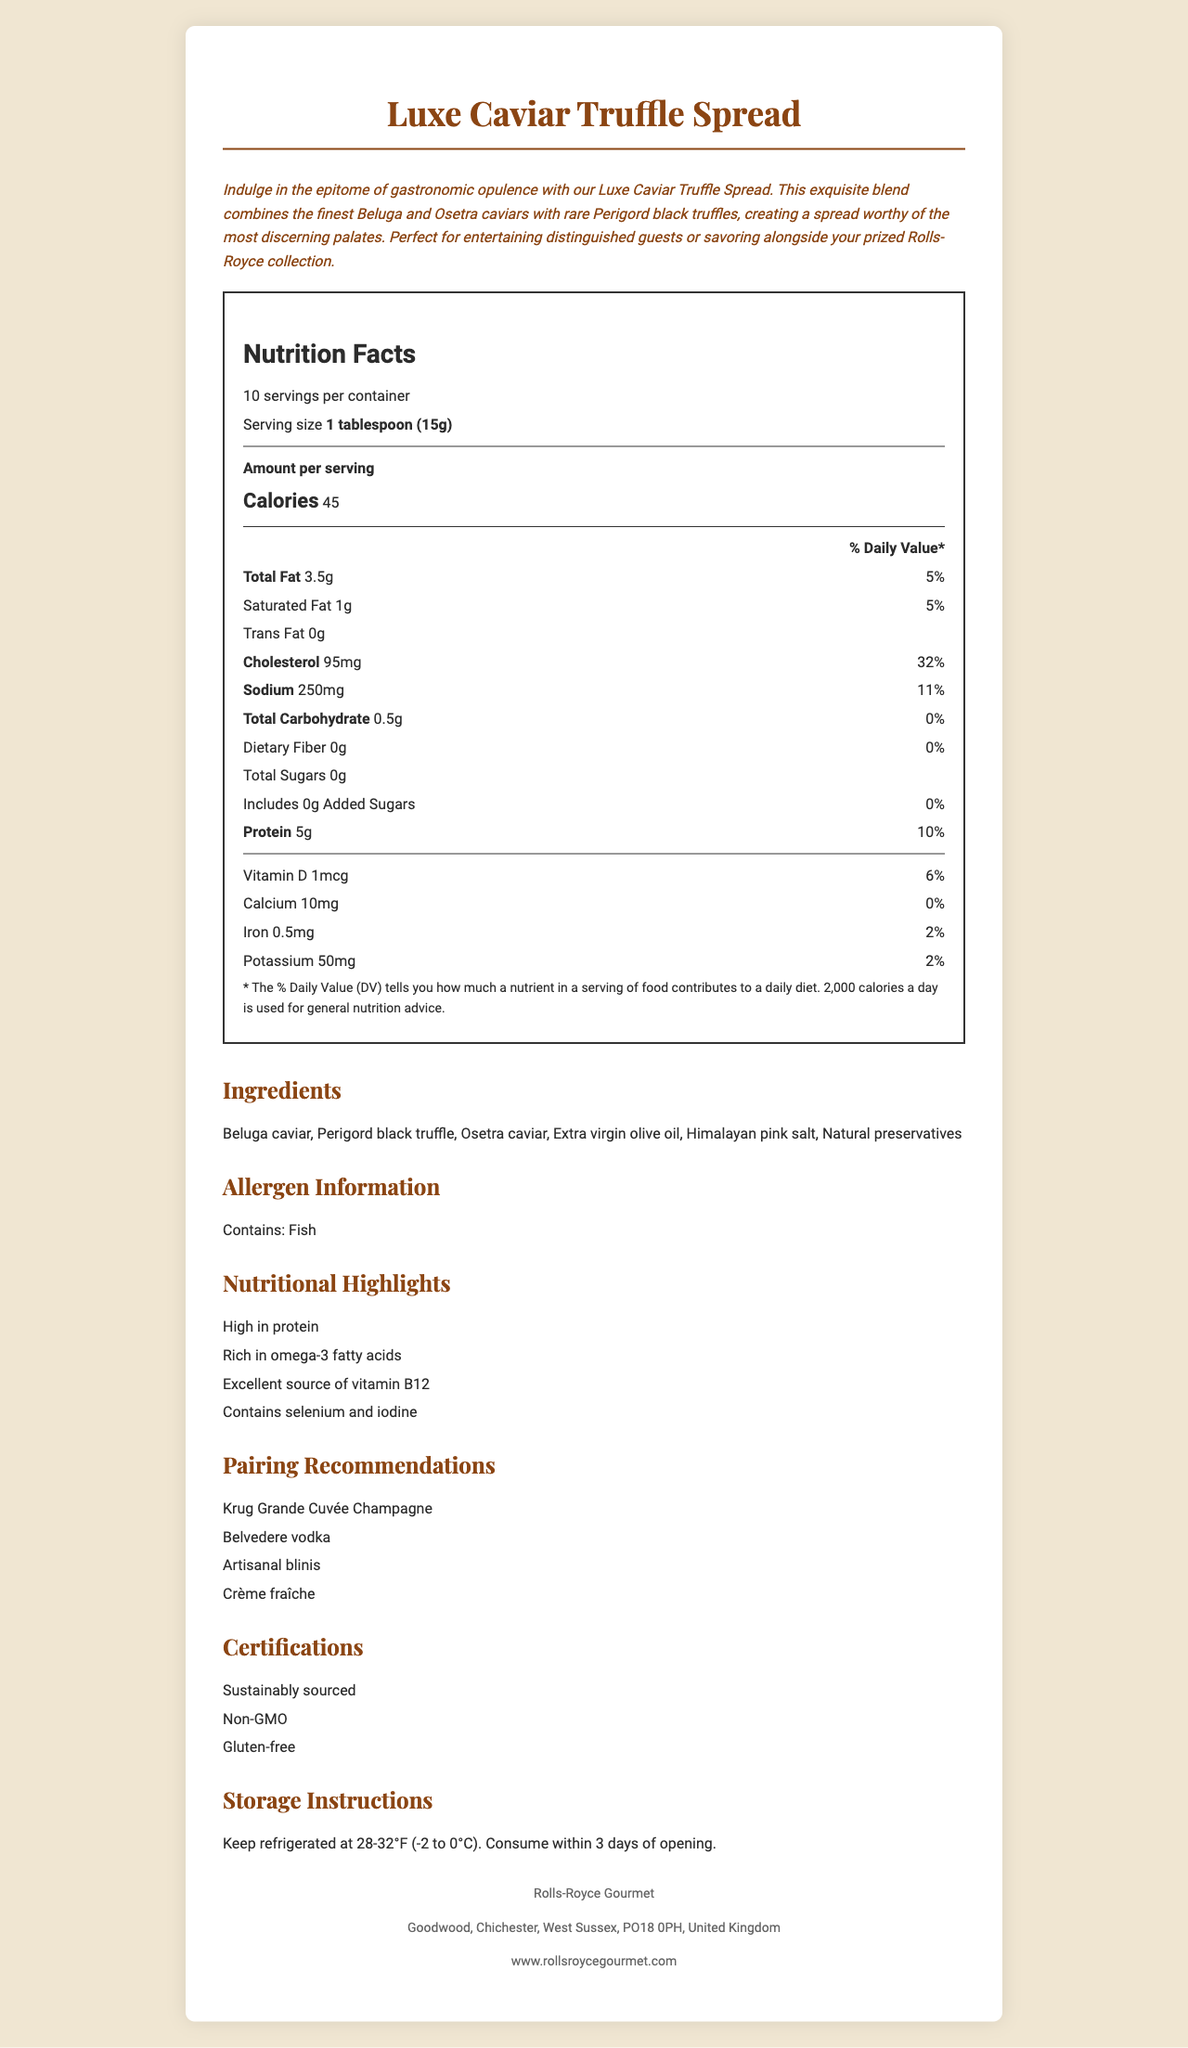how many servings are in one container? The document states "10 servings per container."
Answer: 10 servings what is the serving size of the Luxe Caviar Truffle Spread? The labeled serving size is specified as "1 tablespoon (15g)."
Answer: 1 tablespoon (15g) how many grams of protein are in one serving? According to the document, one serving contains 5 grams of protein.
Answer: 5g which pair is NOT recommended with the Luxe Caviar Truffle Spread?  
A. Krug Grande Cuvée Champagne  
B. Belvedere vodka  
C. Toasted whole wheat bread  
D. Artisanal blinis The document mentions pairing recommendations including "Krug Grande Cuvée Champagne," "Belvedere vodka," "Artisanal blinis," but not "Toasted whole wheat bread."
Answer: C how many calories are in one serving? The document states that there are 45 calories per serving.
Answer: 45 calories does the Luxe Caviar Truffle Spread contain any added sugars? The document explicitly mentions "Includes 0g Added Sugars."
Answer: No what is the percentage of the daily value for cholesterol per serving? The document specifies that one serving contains 32% of the daily value for cholesterol.
Answer: 32% which of the following ingredients is NOT in the Luxe Caviar Truffle Spread?  
I. Beluga caviar  
II. Perigord black truffle  
III. Saffron  
IV. Osetra caviar  
V. Himalayan pink salt The listed ingredients in the document include "Beluga caviar," "Perigord black truffle," "Osetra caviar," and "Himalayan pink salt," but not "Saffron."
Answer: III is the Luxe Caviar Truffle Spread gluten-free? The certifications listed in the document include "Gluten-free."
Answer: Yes whom is the manufacturer of the Luxe Caviar Truffle Spread? The manufacturer information specifies "Rolls-Royce Gourmet."
Answer: Rolls-Royce Gourmet is this product suitable for vegans? The allergen information indicates it “Contains: Fish”, making it unsuitable for vegans.
Answer: No what are the storage instructions for the Luxe Caviar Truffle Spread? The document provides these specific storage instructions directly.
Answer: Keep refrigerated at 28-32°F (-2 to 0°C). Consume within 3 days of opening. what is the main idea of the document? Explanation: The document covers various aspects of the Luxe Caviar Truffle Spread: the nutritional label, ingredients, luxury description, allergen information, nutritional highlights, pairing recommendations, certifications, storage instructions, and manufacturer details.
Answer: Summary: The document provides a detailed description of the Luxe Caviar Truffle Spread, including its nutritional facts, lavish ingredients, pairing recommendations, certifications, allergen information, and storage instructions. what is the source of vitamin B12 in the Luxe Caviar Truffle Spread? The document does not provide specific information about the source of vitamin B12 in the product.
Answer: I don't know 